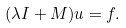<formula> <loc_0><loc_0><loc_500><loc_500>( \lambda I + M ) u = f .</formula> 